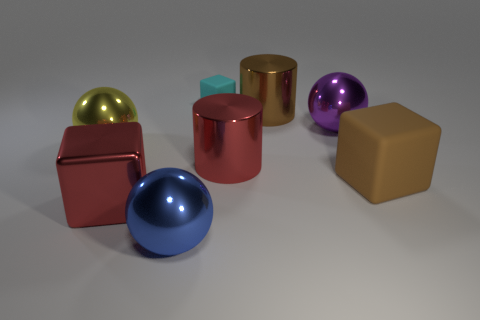Is there a blue matte cylinder that has the same size as the cyan thing?
Provide a short and direct response. No. What shape is the red metal object to the right of the big red metallic thing in front of the matte cube right of the small cyan rubber cube?
Provide a succinct answer. Cylinder. Are there more shiny objects in front of the purple metallic sphere than brown metal cylinders?
Make the answer very short. Yes. Are there any big blue things that have the same shape as the yellow thing?
Offer a very short reply. Yes. Is the material of the big brown cylinder the same as the large cube on the left side of the large blue metallic object?
Offer a terse response. Yes. The tiny matte cube is what color?
Give a very brief answer. Cyan. There is a large brown block to the right of the object that is on the left side of the red shiny cube; what number of shiny cylinders are behind it?
Give a very brief answer. 2. There is a purple metal sphere; are there any rubber blocks in front of it?
Offer a very short reply. Yes. How many big brown cubes are made of the same material as the yellow sphere?
Offer a very short reply. 0. How many objects are large blue matte cylinders or metal balls?
Offer a very short reply. 3. 